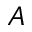<formula> <loc_0><loc_0><loc_500><loc_500>A</formula> 